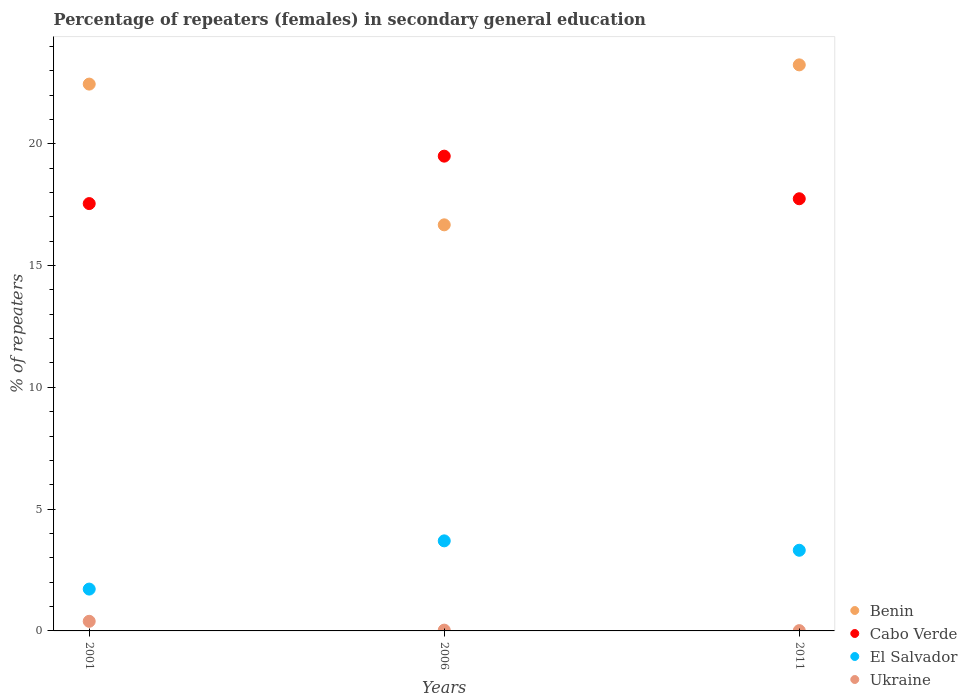How many different coloured dotlines are there?
Make the answer very short. 4. What is the percentage of female repeaters in El Salvador in 2006?
Your response must be concise. 3.7. Across all years, what is the maximum percentage of female repeaters in Cabo Verde?
Keep it short and to the point. 19.49. Across all years, what is the minimum percentage of female repeaters in Ukraine?
Your answer should be very brief. 0.01. What is the total percentage of female repeaters in Ukraine in the graph?
Give a very brief answer. 0.44. What is the difference between the percentage of female repeaters in Cabo Verde in 2001 and that in 2011?
Provide a succinct answer. -0.2. What is the difference between the percentage of female repeaters in El Salvador in 2006 and the percentage of female repeaters in Ukraine in 2001?
Offer a terse response. 3.3. What is the average percentage of female repeaters in Benin per year?
Provide a succinct answer. 20.79. In the year 2006, what is the difference between the percentage of female repeaters in Ukraine and percentage of female repeaters in El Salvador?
Make the answer very short. -3.66. In how many years, is the percentage of female repeaters in Cabo Verde greater than 21 %?
Your answer should be compact. 0. What is the ratio of the percentage of female repeaters in Cabo Verde in 2001 to that in 2011?
Give a very brief answer. 0.99. Is the difference between the percentage of female repeaters in Ukraine in 2001 and 2011 greater than the difference between the percentage of female repeaters in El Salvador in 2001 and 2011?
Provide a short and direct response. Yes. What is the difference between the highest and the second highest percentage of female repeaters in Benin?
Ensure brevity in your answer.  0.79. What is the difference between the highest and the lowest percentage of female repeaters in Ukraine?
Give a very brief answer. 0.38. In how many years, is the percentage of female repeaters in Cabo Verde greater than the average percentage of female repeaters in Cabo Verde taken over all years?
Your answer should be compact. 1. Is the sum of the percentage of female repeaters in Benin in 2001 and 2006 greater than the maximum percentage of female repeaters in Cabo Verde across all years?
Ensure brevity in your answer.  Yes. Is the percentage of female repeaters in El Salvador strictly greater than the percentage of female repeaters in Ukraine over the years?
Provide a short and direct response. Yes. Is the percentage of female repeaters in Ukraine strictly less than the percentage of female repeaters in Benin over the years?
Your answer should be compact. Yes. How many years are there in the graph?
Keep it short and to the point. 3. Are the values on the major ticks of Y-axis written in scientific E-notation?
Your answer should be very brief. No. Where does the legend appear in the graph?
Provide a short and direct response. Bottom right. What is the title of the graph?
Provide a short and direct response. Percentage of repeaters (females) in secondary general education. Does "Eritrea" appear as one of the legend labels in the graph?
Provide a short and direct response. No. What is the label or title of the X-axis?
Your response must be concise. Years. What is the label or title of the Y-axis?
Provide a short and direct response. % of repeaters. What is the % of repeaters in Benin in 2001?
Keep it short and to the point. 22.45. What is the % of repeaters of Cabo Verde in 2001?
Offer a terse response. 17.54. What is the % of repeaters in El Salvador in 2001?
Ensure brevity in your answer.  1.72. What is the % of repeaters in Ukraine in 2001?
Make the answer very short. 0.4. What is the % of repeaters in Benin in 2006?
Ensure brevity in your answer.  16.67. What is the % of repeaters of Cabo Verde in 2006?
Your answer should be very brief. 19.49. What is the % of repeaters of El Salvador in 2006?
Provide a succinct answer. 3.7. What is the % of repeaters of Ukraine in 2006?
Make the answer very short. 0.03. What is the % of repeaters in Benin in 2011?
Your answer should be very brief. 23.24. What is the % of repeaters of Cabo Verde in 2011?
Give a very brief answer. 17.74. What is the % of repeaters of El Salvador in 2011?
Provide a short and direct response. 3.31. What is the % of repeaters in Ukraine in 2011?
Provide a short and direct response. 0.01. Across all years, what is the maximum % of repeaters of Benin?
Make the answer very short. 23.24. Across all years, what is the maximum % of repeaters in Cabo Verde?
Your response must be concise. 19.49. Across all years, what is the maximum % of repeaters of El Salvador?
Offer a terse response. 3.7. Across all years, what is the maximum % of repeaters of Ukraine?
Keep it short and to the point. 0.4. Across all years, what is the minimum % of repeaters in Benin?
Offer a terse response. 16.67. Across all years, what is the minimum % of repeaters in Cabo Verde?
Provide a succinct answer. 17.54. Across all years, what is the minimum % of repeaters in El Salvador?
Offer a very short reply. 1.72. Across all years, what is the minimum % of repeaters in Ukraine?
Offer a terse response. 0.01. What is the total % of repeaters of Benin in the graph?
Provide a short and direct response. 62.36. What is the total % of repeaters of Cabo Verde in the graph?
Offer a very short reply. 54.77. What is the total % of repeaters in El Salvador in the graph?
Make the answer very short. 8.73. What is the total % of repeaters of Ukraine in the graph?
Make the answer very short. 0.44. What is the difference between the % of repeaters in Benin in 2001 and that in 2006?
Ensure brevity in your answer.  5.78. What is the difference between the % of repeaters of Cabo Verde in 2001 and that in 2006?
Your response must be concise. -1.95. What is the difference between the % of repeaters in El Salvador in 2001 and that in 2006?
Your answer should be compact. -1.98. What is the difference between the % of repeaters of Ukraine in 2001 and that in 2006?
Your response must be concise. 0.36. What is the difference between the % of repeaters in Benin in 2001 and that in 2011?
Make the answer very short. -0.79. What is the difference between the % of repeaters in Cabo Verde in 2001 and that in 2011?
Offer a terse response. -0.2. What is the difference between the % of repeaters in El Salvador in 2001 and that in 2011?
Offer a very short reply. -1.59. What is the difference between the % of repeaters in Ukraine in 2001 and that in 2011?
Ensure brevity in your answer.  0.38. What is the difference between the % of repeaters in Benin in 2006 and that in 2011?
Your answer should be compact. -6.57. What is the difference between the % of repeaters of Cabo Verde in 2006 and that in 2011?
Give a very brief answer. 1.75. What is the difference between the % of repeaters of El Salvador in 2006 and that in 2011?
Ensure brevity in your answer.  0.39. What is the difference between the % of repeaters in Ukraine in 2006 and that in 2011?
Provide a short and direct response. 0.02. What is the difference between the % of repeaters of Benin in 2001 and the % of repeaters of Cabo Verde in 2006?
Your answer should be compact. 2.96. What is the difference between the % of repeaters of Benin in 2001 and the % of repeaters of El Salvador in 2006?
Offer a terse response. 18.75. What is the difference between the % of repeaters in Benin in 2001 and the % of repeaters in Ukraine in 2006?
Your answer should be compact. 22.42. What is the difference between the % of repeaters in Cabo Verde in 2001 and the % of repeaters in El Salvador in 2006?
Your response must be concise. 13.85. What is the difference between the % of repeaters in Cabo Verde in 2001 and the % of repeaters in Ukraine in 2006?
Make the answer very short. 17.51. What is the difference between the % of repeaters in El Salvador in 2001 and the % of repeaters in Ukraine in 2006?
Keep it short and to the point. 1.68. What is the difference between the % of repeaters of Benin in 2001 and the % of repeaters of Cabo Verde in 2011?
Provide a short and direct response. 4.71. What is the difference between the % of repeaters in Benin in 2001 and the % of repeaters in El Salvador in 2011?
Offer a terse response. 19.14. What is the difference between the % of repeaters of Benin in 2001 and the % of repeaters of Ukraine in 2011?
Give a very brief answer. 22.44. What is the difference between the % of repeaters of Cabo Verde in 2001 and the % of repeaters of El Salvador in 2011?
Your answer should be compact. 14.23. What is the difference between the % of repeaters of Cabo Verde in 2001 and the % of repeaters of Ukraine in 2011?
Ensure brevity in your answer.  17.53. What is the difference between the % of repeaters in El Salvador in 2001 and the % of repeaters in Ukraine in 2011?
Your response must be concise. 1.71. What is the difference between the % of repeaters in Benin in 2006 and the % of repeaters in Cabo Verde in 2011?
Provide a short and direct response. -1.07. What is the difference between the % of repeaters of Benin in 2006 and the % of repeaters of El Salvador in 2011?
Offer a very short reply. 13.36. What is the difference between the % of repeaters in Benin in 2006 and the % of repeaters in Ukraine in 2011?
Offer a very short reply. 16.66. What is the difference between the % of repeaters in Cabo Verde in 2006 and the % of repeaters in El Salvador in 2011?
Make the answer very short. 16.18. What is the difference between the % of repeaters in Cabo Verde in 2006 and the % of repeaters in Ukraine in 2011?
Your answer should be compact. 19.48. What is the difference between the % of repeaters in El Salvador in 2006 and the % of repeaters in Ukraine in 2011?
Your answer should be compact. 3.69. What is the average % of repeaters of Benin per year?
Offer a very short reply. 20.79. What is the average % of repeaters in Cabo Verde per year?
Keep it short and to the point. 18.26. What is the average % of repeaters of El Salvador per year?
Your answer should be compact. 2.91. What is the average % of repeaters in Ukraine per year?
Offer a very short reply. 0.15. In the year 2001, what is the difference between the % of repeaters in Benin and % of repeaters in Cabo Verde?
Offer a terse response. 4.9. In the year 2001, what is the difference between the % of repeaters in Benin and % of repeaters in El Salvador?
Provide a succinct answer. 20.73. In the year 2001, what is the difference between the % of repeaters of Benin and % of repeaters of Ukraine?
Make the answer very short. 22.05. In the year 2001, what is the difference between the % of repeaters in Cabo Verde and % of repeaters in El Salvador?
Your answer should be compact. 15.83. In the year 2001, what is the difference between the % of repeaters of Cabo Verde and % of repeaters of Ukraine?
Ensure brevity in your answer.  17.15. In the year 2001, what is the difference between the % of repeaters in El Salvador and % of repeaters in Ukraine?
Give a very brief answer. 1.32. In the year 2006, what is the difference between the % of repeaters in Benin and % of repeaters in Cabo Verde?
Provide a short and direct response. -2.82. In the year 2006, what is the difference between the % of repeaters in Benin and % of repeaters in El Salvador?
Your response must be concise. 12.97. In the year 2006, what is the difference between the % of repeaters of Benin and % of repeaters of Ukraine?
Your answer should be compact. 16.64. In the year 2006, what is the difference between the % of repeaters in Cabo Verde and % of repeaters in El Salvador?
Your answer should be very brief. 15.79. In the year 2006, what is the difference between the % of repeaters of Cabo Verde and % of repeaters of Ukraine?
Your answer should be compact. 19.46. In the year 2006, what is the difference between the % of repeaters in El Salvador and % of repeaters in Ukraine?
Give a very brief answer. 3.66. In the year 2011, what is the difference between the % of repeaters of Benin and % of repeaters of Cabo Verde?
Your answer should be compact. 5.5. In the year 2011, what is the difference between the % of repeaters of Benin and % of repeaters of El Salvador?
Keep it short and to the point. 19.93. In the year 2011, what is the difference between the % of repeaters in Benin and % of repeaters in Ukraine?
Ensure brevity in your answer.  23.23. In the year 2011, what is the difference between the % of repeaters of Cabo Verde and % of repeaters of El Salvador?
Give a very brief answer. 14.43. In the year 2011, what is the difference between the % of repeaters in Cabo Verde and % of repeaters in Ukraine?
Make the answer very short. 17.73. In the year 2011, what is the difference between the % of repeaters of El Salvador and % of repeaters of Ukraine?
Your answer should be compact. 3.3. What is the ratio of the % of repeaters of Benin in 2001 to that in 2006?
Provide a succinct answer. 1.35. What is the ratio of the % of repeaters of Cabo Verde in 2001 to that in 2006?
Your answer should be compact. 0.9. What is the ratio of the % of repeaters in El Salvador in 2001 to that in 2006?
Your answer should be very brief. 0.46. What is the ratio of the % of repeaters of Ukraine in 2001 to that in 2006?
Provide a succinct answer. 12.1. What is the ratio of the % of repeaters of Cabo Verde in 2001 to that in 2011?
Your response must be concise. 0.99. What is the ratio of the % of repeaters of El Salvador in 2001 to that in 2011?
Make the answer very short. 0.52. What is the ratio of the % of repeaters of Ukraine in 2001 to that in 2011?
Your answer should be compact. 33.94. What is the ratio of the % of repeaters in Benin in 2006 to that in 2011?
Your response must be concise. 0.72. What is the ratio of the % of repeaters of Cabo Verde in 2006 to that in 2011?
Make the answer very short. 1.1. What is the ratio of the % of repeaters in El Salvador in 2006 to that in 2011?
Offer a terse response. 1.12. What is the ratio of the % of repeaters of Ukraine in 2006 to that in 2011?
Your answer should be very brief. 2.81. What is the difference between the highest and the second highest % of repeaters in Benin?
Keep it short and to the point. 0.79. What is the difference between the highest and the second highest % of repeaters in Cabo Verde?
Provide a succinct answer. 1.75. What is the difference between the highest and the second highest % of repeaters of El Salvador?
Keep it short and to the point. 0.39. What is the difference between the highest and the second highest % of repeaters in Ukraine?
Offer a very short reply. 0.36. What is the difference between the highest and the lowest % of repeaters in Benin?
Keep it short and to the point. 6.57. What is the difference between the highest and the lowest % of repeaters in Cabo Verde?
Your response must be concise. 1.95. What is the difference between the highest and the lowest % of repeaters of El Salvador?
Ensure brevity in your answer.  1.98. What is the difference between the highest and the lowest % of repeaters in Ukraine?
Your answer should be very brief. 0.38. 